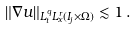Convert formula to latex. <formula><loc_0><loc_0><loc_500><loc_500>\| \nabla u \| _ { L _ { t } ^ { q } L _ { x } ^ { r } ( I _ { j } \times \Omega ) } \lesssim 1 \, .</formula> 